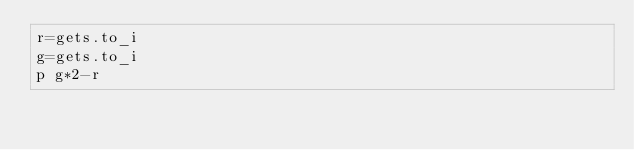Convert code to text. <code><loc_0><loc_0><loc_500><loc_500><_Ruby_>r=gets.to_i
g=gets.to_i
p g*2-r
</code> 